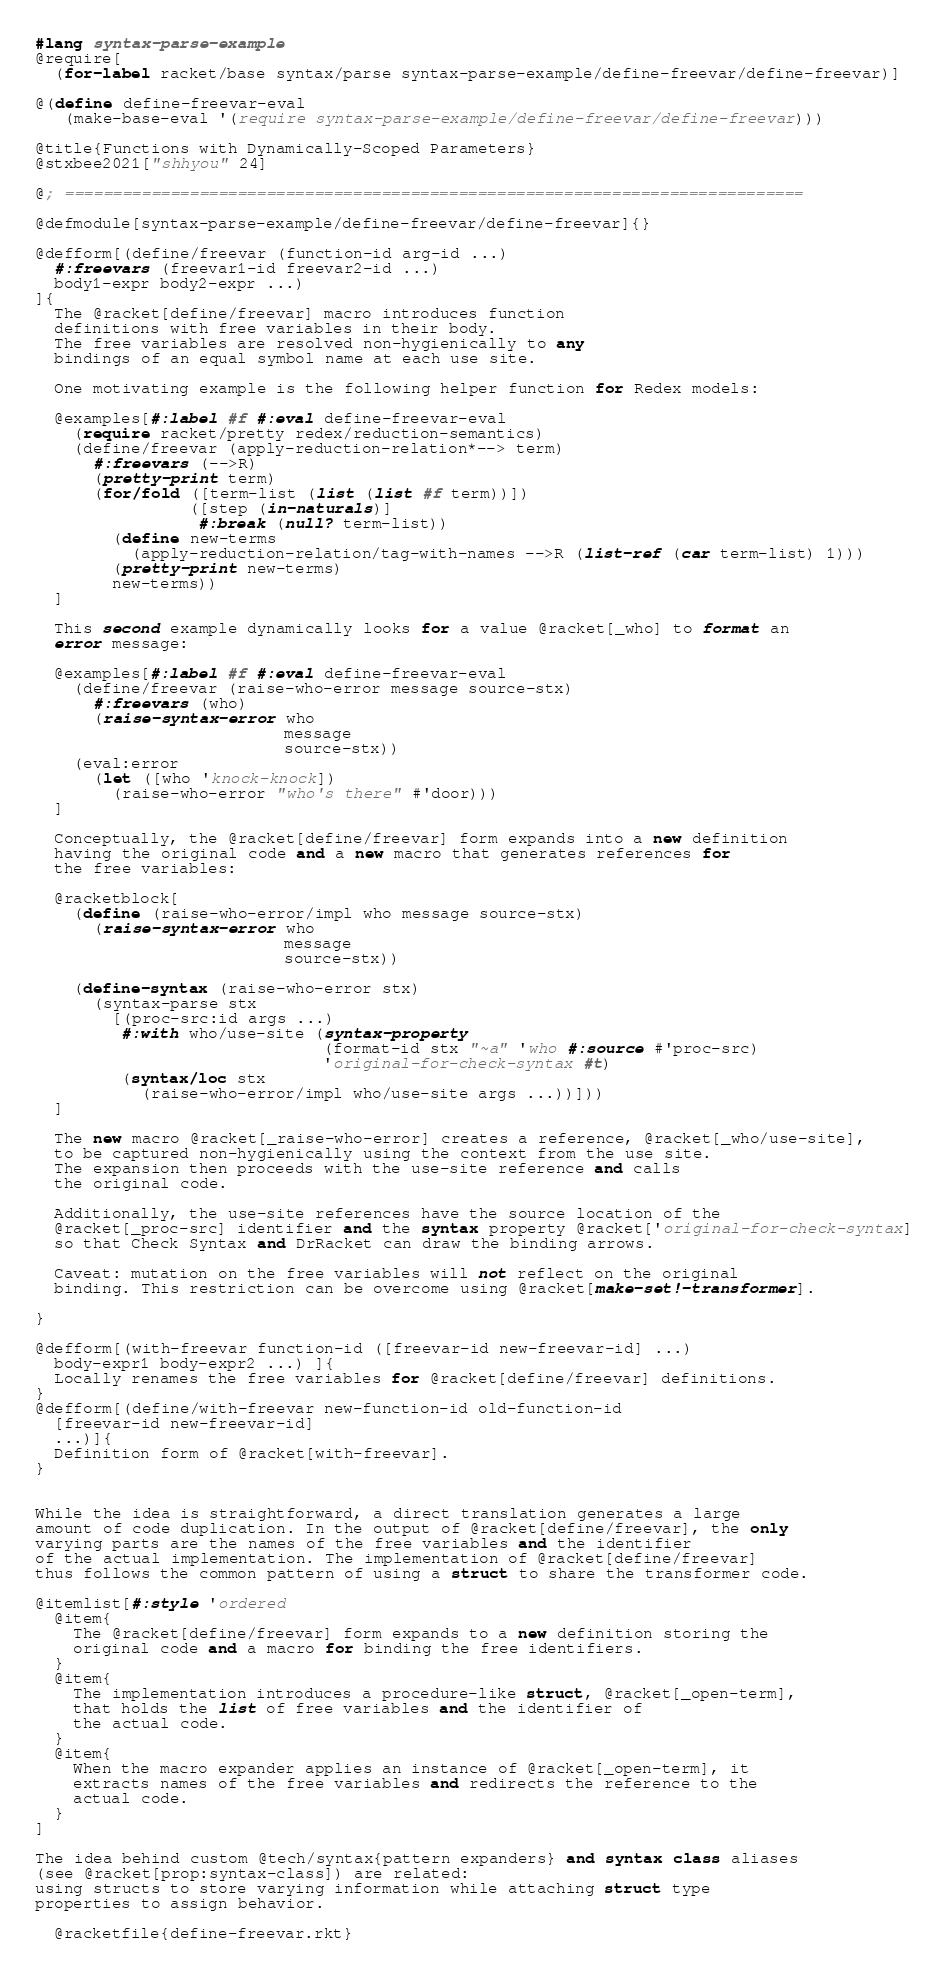<code> <loc_0><loc_0><loc_500><loc_500><_Racket_>#lang syntax-parse-example
@require[
  (for-label racket/base syntax/parse syntax-parse-example/define-freevar/define-freevar)]

@(define define-freevar-eval
   (make-base-eval '(require syntax-parse-example/define-freevar/define-freevar)))

@title{Functions with Dynamically-Scoped Parameters}
@stxbee2021["shhyou" 24]

@; =============================================================================

@defmodule[syntax-parse-example/define-freevar/define-freevar]{}

@defform[(define/freevar (function-id arg-id ...)
  #:freevars (freevar1-id freevar2-id ...)
  body1-expr body2-expr ...)
]{
  The @racket[define/freevar] macro introduces function
  definitions with free variables in their body.
  The free variables are resolved non-hygienically to any
  bindings of an equal symbol name at each use site.

  One motivating example is the following helper function for Redex models:

  @examples[#:label #f #:eval define-freevar-eval
    (require racket/pretty redex/reduction-semantics)
    (define/freevar (apply-reduction-relation*--> term)
      #:freevars (-->R)
      (pretty-print term)
      (for/fold ([term-list (list (list #f term))])
                ([step (in-naturals)]
                 #:break (null? term-list))
        (define new-terms
          (apply-reduction-relation/tag-with-names -->R (list-ref (car term-list) 1)))
        (pretty-print new-terms)
        new-terms))
  ]

  This second example dynamically looks for a value @racket[_who] to format an
  error message:

  @examples[#:label #f #:eval define-freevar-eval
    (define/freevar (raise-who-error message source-stx)
      #:freevars (who)
      (raise-syntax-error who
                          message
                          source-stx))
    (eval:error
      (let ([who 'knock-knock])
        (raise-who-error "who's there" #'door)))
  ]

  Conceptually, the @racket[define/freevar] form expands into a new definition
  having the original code and a new macro that generates references for
  the free variables:

  @racketblock[
    (define (raise-who-error/impl who message source-stx)
      (raise-syntax-error who
                          message
                          source-stx))

    (define-syntax (raise-who-error stx)
      (syntax-parse stx
        [(proc-src:id args ...)
         #:with who/use-site (syntax-property
                              (format-id stx "~a" 'who #:source #'proc-src)
                              'original-for-check-syntax #t)
         (syntax/loc stx
           (raise-who-error/impl who/use-site args ...))]))
  ]

  The new macro @racket[_raise-who-error] creates a reference, @racket[_who/use-site],
  to be captured non-hygienically using the context from the use site.
  The expansion then proceeds with the use-site reference and calls
  the original code.

  Additionally, the use-site references have the source location of the
  @racket[_proc-src] identifier and the syntax property @racket['original-for-check-syntax]
  so that Check Syntax and DrRacket can draw the binding arrows.

  Caveat: mutation on the free variables will not reflect on the original
  binding. This restriction can be overcome using @racket[make-set!-transformer].

}

@defform[(with-freevar function-id ([freevar-id new-freevar-id] ...)
  body-expr1 body-expr2 ...) ]{
  Locally renames the free variables for @racket[define/freevar] definitions.
}
@defform[(define/with-freevar new-function-id old-function-id
  [freevar-id new-freevar-id]
  ...)]{
  Definition form of @racket[with-freevar].
}


While the idea is straightforward, a direct translation generates a large
amount of code duplication. In the output of @racket[define/freevar], the only
varying parts are the names of the free variables and the identifier
of the actual implementation. The implementation of @racket[define/freevar]
thus follows the common pattern of using a struct to share the transformer code.

@itemlist[#:style 'ordered
  @item{
    The @racket[define/freevar] form expands to a new definition storing the
    original code and a macro for binding the free identifiers.
  }
  @item{
    The implementation introduces a procedure-like struct, @racket[_open-term],
    that holds the list of free variables and the identifier of
    the actual code.
  }
  @item{
    When the macro expander applies an instance of @racket[_open-term], it
    extracts names of the free variables and redirects the reference to the
    actual code.
  }
]

The idea behind custom @tech/syntax{pattern expanders} and syntax class aliases
(see @racket[prop:syntax-class]) are related:
using structs to store varying information while attaching struct type
properties to assign behavior.

  @racketfile{define-freevar.rkt}

</code> 